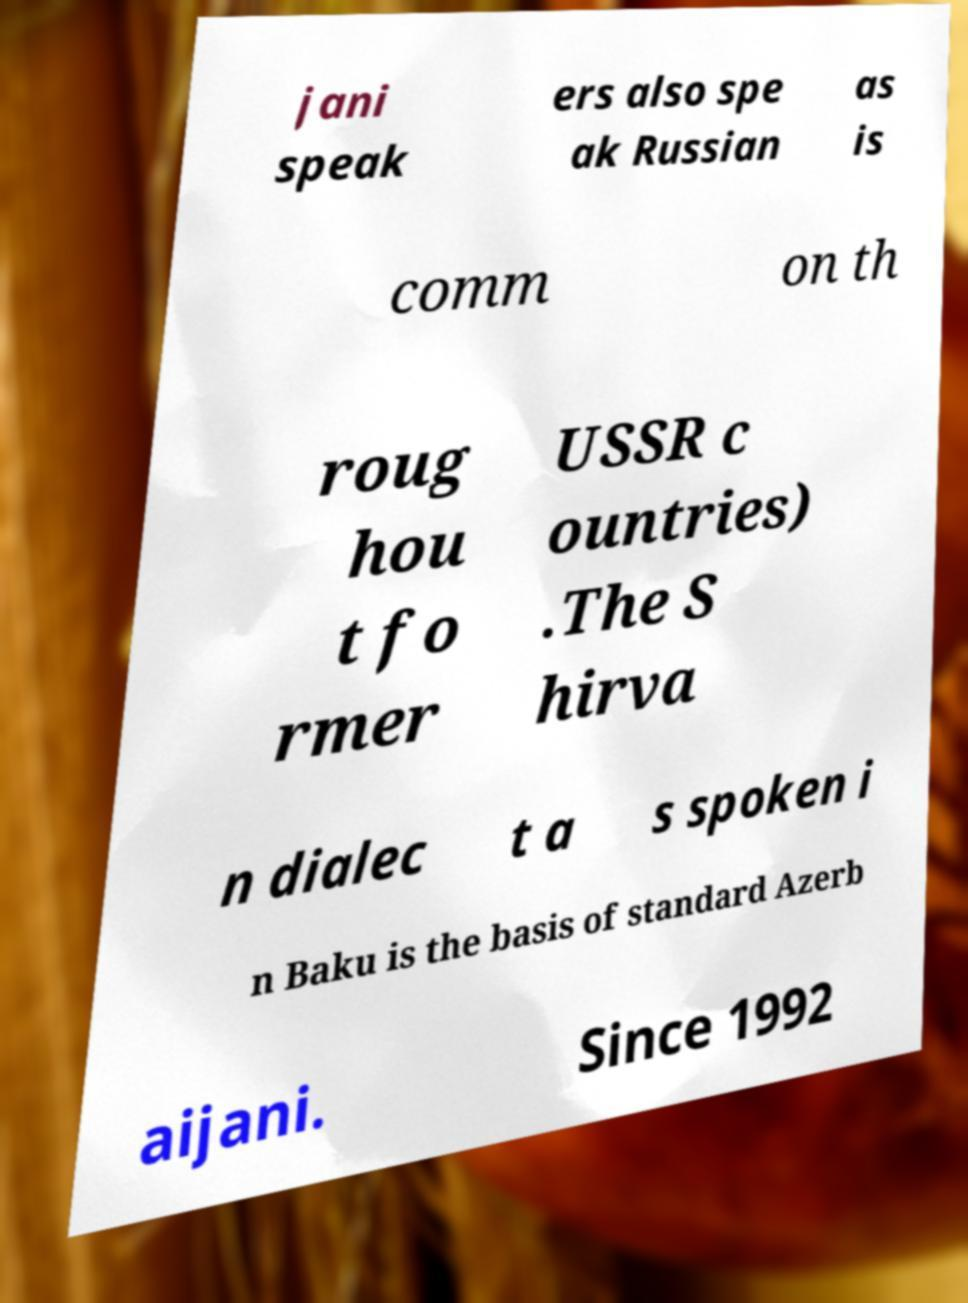What messages or text are displayed in this image? I need them in a readable, typed format. jani speak ers also spe ak Russian as is comm on th roug hou t fo rmer USSR c ountries) .The S hirva n dialec t a s spoken i n Baku is the basis of standard Azerb aijani. Since 1992 